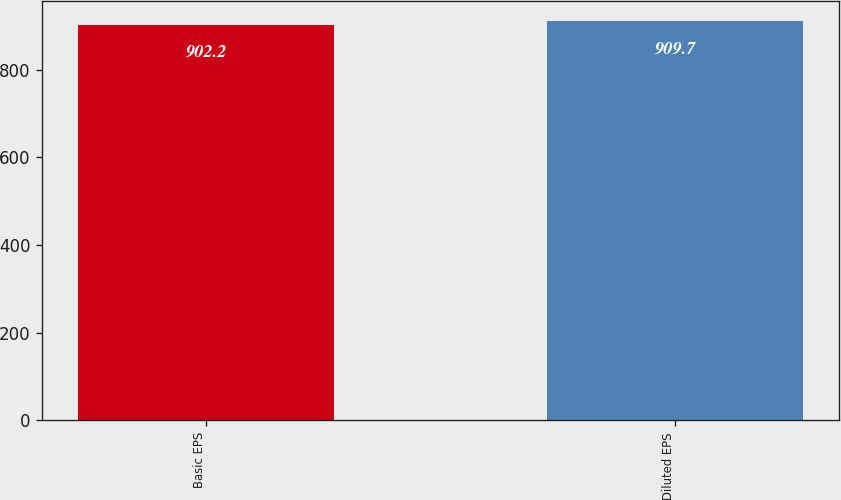<chart> <loc_0><loc_0><loc_500><loc_500><bar_chart><fcel>Basic EPS<fcel>Diluted EPS<nl><fcel>902.2<fcel>909.7<nl></chart> 